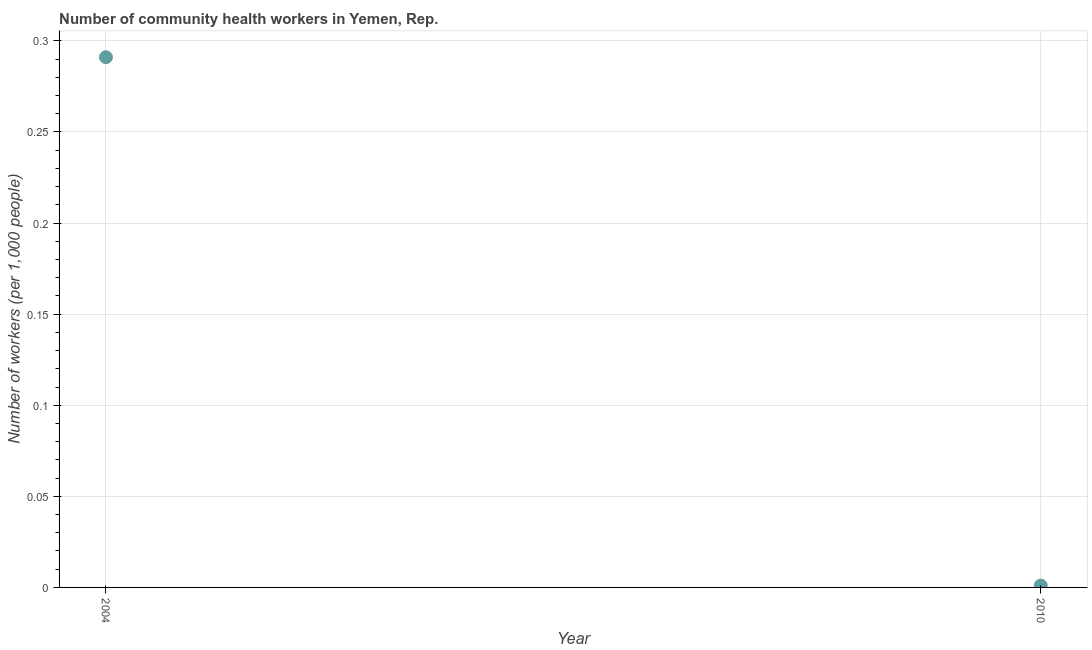What is the number of community health workers in 2004?
Ensure brevity in your answer.  0.29. Across all years, what is the maximum number of community health workers?
Keep it short and to the point. 0.29. In which year was the number of community health workers maximum?
Your response must be concise. 2004. What is the sum of the number of community health workers?
Give a very brief answer. 0.29. What is the difference between the number of community health workers in 2004 and 2010?
Your answer should be compact. 0.29. What is the average number of community health workers per year?
Offer a very short reply. 0.15. What is the median number of community health workers?
Give a very brief answer. 0.15. In how many years, is the number of community health workers greater than 0.14 ?
Provide a succinct answer. 1. What is the ratio of the number of community health workers in 2004 to that in 2010?
Your answer should be very brief. 291. In how many years, is the number of community health workers greater than the average number of community health workers taken over all years?
Offer a very short reply. 1. How many years are there in the graph?
Provide a short and direct response. 2. What is the title of the graph?
Give a very brief answer. Number of community health workers in Yemen, Rep. What is the label or title of the X-axis?
Ensure brevity in your answer.  Year. What is the label or title of the Y-axis?
Provide a succinct answer. Number of workers (per 1,0 people). What is the Number of workers (per 1,000 people) in 2004?
Provide a short and direct response. 0.29. What is the difference between the Number of workers (per 1,000 people) in 2004 and 2010?
Give a very brief answer. 0.29. What is the ratio of the Number of workers (per 1,000 people) in 2004 to that in 2010?
Provide a succinct answer. 291. 